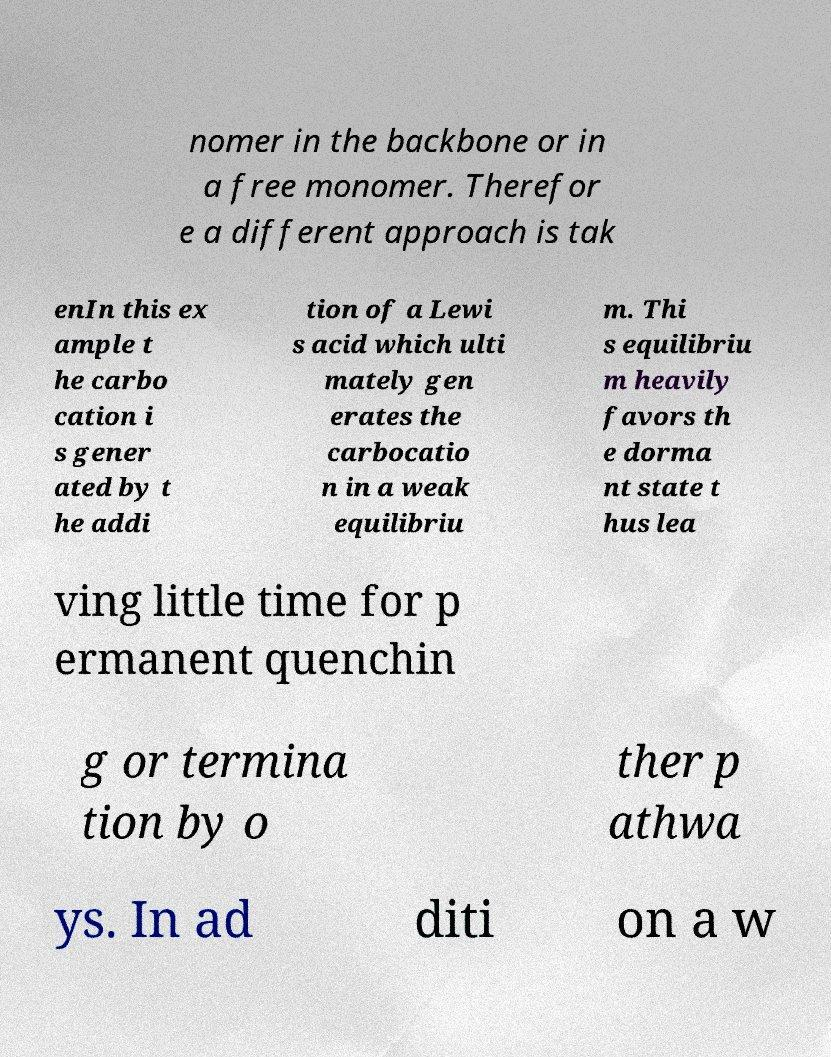Could you extract and type out the text from this image? nomer in the backbone or in a free monomer. Therefor e a different approach is tak enIn this ex ample t he carbo cation i s gener ated by t he addi tion of a Lewi s acid which ulti mately gen erates the carbocatio n in a weak equilibriu m. Thi s equilibriu m heavily favors th e dorma nt state t hus lea ving little time for p ermanent quenchin g or termina tion by o ther p athwa ys. In ad diti on a w 